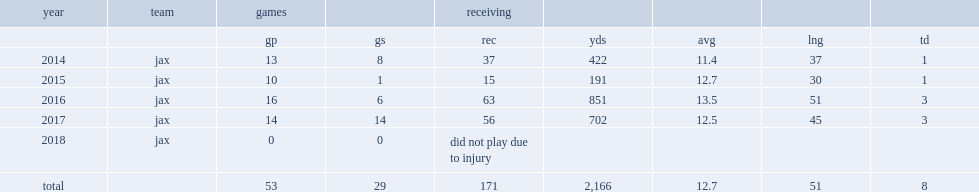When did marqise lee finish his rookie season with 37 receptions for 422 yards and one touchdown in 13 games and eight starts? 2014.0. 